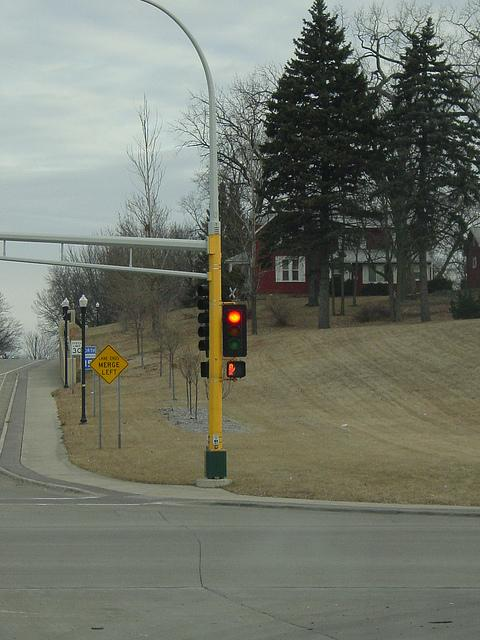Where is the house located? Please explain your reasoning. hill. You can see that the house is not on steady land. 